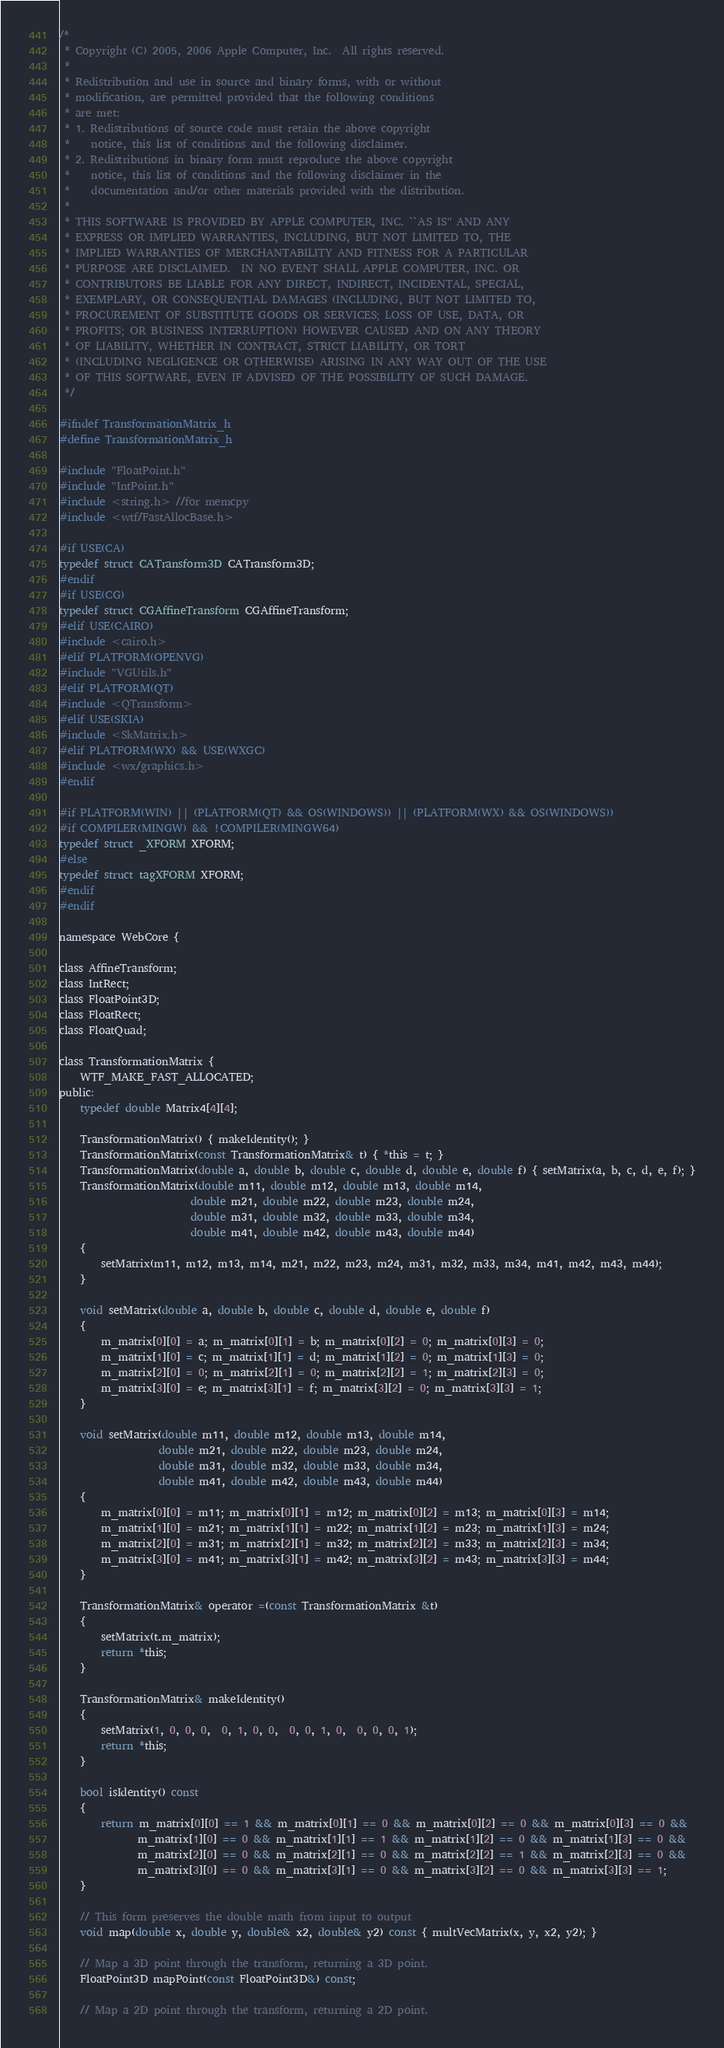<code> <loc_0><loc_0><loc_500><loc_500><_C_>/*
 * Copyright (C) 2005, 2006 Apple Computer, Inc.  All rights reserved.
 *
 * Redistribution and use in source and binary forms, with or without
 * modification, are permitted provided that the following conditions
 * are met:
 * 1. Redistributions of source code must retain the above copyright
 *    notice, this list of conditions and the following disclaimer.
 * 2. Redistributions in binary form must reproduce the above copyright
 *    notice, this list of conditions and the following disclaimer in the
 *    documentation and/or other materials provided with the distribution.
 *
 * THIS SOFTWARE IS PROVIDED BY APPLE COMPUTER, INC. ``AS IS'' AND ANY
 * EXPRESS OR IMPLIED WARRANTIES, INCLUDING, BUT NOT LIMITED TO, THE
 * IMPLIED WARRANTIES OF MERCHANTABILITY AND FITNESS FOR A PARTICULAR
 * PURPOSE ARE DISCLAIMED.  IN NO EVENT SHALL APPLE COMPUTER, INC. OR
 * CONTRIBUTORS BE LIABLE FOR ANY DIRECT, INDIRECT, INCIDENTAL, SPECIAL,
 * EXEMPLARY, OR CONSEQUENTIAL DAMAGES (INCLUDING, BUT NOT LIMITED TO,
 * PROCUREMENT OF SUBSTITUTE GOODS OR SERVICES; LOSS OF USE, DATA, OR
 * PROFITS; OR BUSINESS INTERRUPTION) HOWEVER CAUSED AND ON ANY THEORY
 * OF LIABILITY, WHETHER IN CONTRACT, STRICT LIABILITY, OR TORT
 * (INCLUDING NEGLIGENCE OR OTHERWISE) ARISING IN ANY WAY OUT OF THE USE
 * OF THIS SOFTWARE, EVEN IF ADVISED OF THE POSSIBILITY OF SUCH DAMAGE.
 */

#ifndef TransformationMatrix_h
#define TransformationMatrix_h

#include "FloatPoint.h"
#include "IntPoint.h"
#include <string.h> //for memcpy
#include <wtf/FastAllocBase.h>

#if USE(CA)
typedef struct CATransform3D CATransform3D;
#endif
#if USE(CG)
typedef struct CGAffineTransform CGAffineTransform;
#elif USE(CAIRO)
#include <cairo.h>
#elif PLATFORM(OPENVG)
#include "VGUtils.h"
#elif PLATFORM(QT)
#include <QTransform>
#elif USE(SKIA)
#include <SkMatrix.h>
#elif PLATFORM(WX) && USE(WXGC)
#include <wx/graphics.h>
#endif

#if PLATFORM(WIN) || (PLATFORM(QT) && OS(WINDOWS)) || (PLATFORM(WX) && OS(WINDOWS))
#if COMPILER(MINGW) && !COMPILER(MINGW64)
typedef struct _XFORM XFORM;
#else
typedef struct tagXFORM XFORM;
#endif
#endif

namespace WebCore {

class AffineTransform;
class IntRect;
class FloatPoint3D;
class FloatRect;
class FloatQuad;

class TransformationMatrix {
    WTF_MAKE_FAST_ALLOCATED;
public:
    typedef double Matrix4[4][4];

    TransformationMatrix() { makeIdentity(); }
    TransformationMatrix(const TransformationMatrix& t) { *this = t; }
    TransformationMatrix(double a, double b, double c, double d, double e, double f) { setMatrix(a, b, c, d, e, f); }
    TransformationMatrix(double m11, double m12, double m13, double m14,
                         double m21, double m22, double m23, double m24,
                         double m31, double m32, double m33, double m34,
                         double m41, double m42, double m43, double m44)
    {
        setMatrix(m11, m12, m13, m14, m21, m22, m23, m24, m31, m32, m33, m34, m41, m42, m43, m44);
    }

    void setMatrix(double a, double b, double c, double d, double e, double f)
    {
        m_matrix[0][0] = a; m_matrix[0][1] = b; m_matrix[0][2] = 0; m_matrix[0][3] = 0; 
        m_matrix[1][0] = c; m_matrix[1][1] = d; m_matrix[1][2] = 0; m_matrix[1][3] = 0; 
        m_matrix[2][0] = 0; m_matrix[2][1] = 0; m_matrix[2][2] = 1; m_matrix[2][3] = 0; 
        m_matrix[3][0] = e; m_matrix[3][1] = f; m_matrix[3][2] = 0; m_matrix[3][3] = 1;
    }
    
    void setMatrix(double m11, double m12, double m13, double m14,
                   double m21, double m22, double m23, double m24,
                   double m31, double m32, double m33, double m34,
                   double m41, double m42, double m43, double m44)
    {
        m_matrix[0][0] = m11; m_matrix[0][1] = m12; m_matrix[0][2] = m13; m_matrix[0][3] = m14; 
        m_matrix[1][0] = m21; m_matrix[1][1] = m22; m_matrix[1][2] = m23; m_matrix[1][3] = m24; 
        m_matrix[2][0] = m31; m_matrix[2][1] = m32; m_matrix[2][2] = m33; m_matrix[2][3] = m34; 
        m_matrix[3][0] = m41; m_matrix[3][1] = m42; m_matrix[3][2] = m43; m_matrix[3][3] = m44;
    }
    
    TransformationMatrix& operator =(const TransformationMatrix &t)
    {
        setMatrix(t.m_matrix);
        return *this;
    }

    TransformationMatrix& makeIdentity()
    {
        setMatrix(1, 0, 0, 0,  0, 1, 0, 0,  0, 0, 1, 0,  0, 0, 0, 1);
        return *this;
    }

    bool isIdentity() const
    {
        return m_matrix[0][0] == 1 && m_matrix[0][1] == 0 && m_matrix[0][2] == 0 && m_matrix[0][3] == 0 &&
               m_matrix[1][0] == 0 && m_matrix[1][1] == 1 && m_matrix[1][2] == 0 && m_matrix[1][3] == 0 &&
               m_matrix[2][0] == 0 && m_matrix[2][1] == 0 && m_matrix[2][2] == 1 && m_matrix[2][3] == 0 &&
               m_matrix[3][0] == 0 && m_matrix[3][1] == 0 && m_matrix[3][2] == 0 && m_matrix[3][3] == 1;
    }

    // This form preserves the double math from input to output
    void map(double x, double y, double& x2, double& y2) const { multVecMatrix(x, y, x2, y2); }

    // Map a 3D point through the transform, returning a 3D point.
    FloatPoint3D mapPoint(const FloatPoint3D&) const;

    // Map a 2D point through the transform, returning a 2D point.</code> 